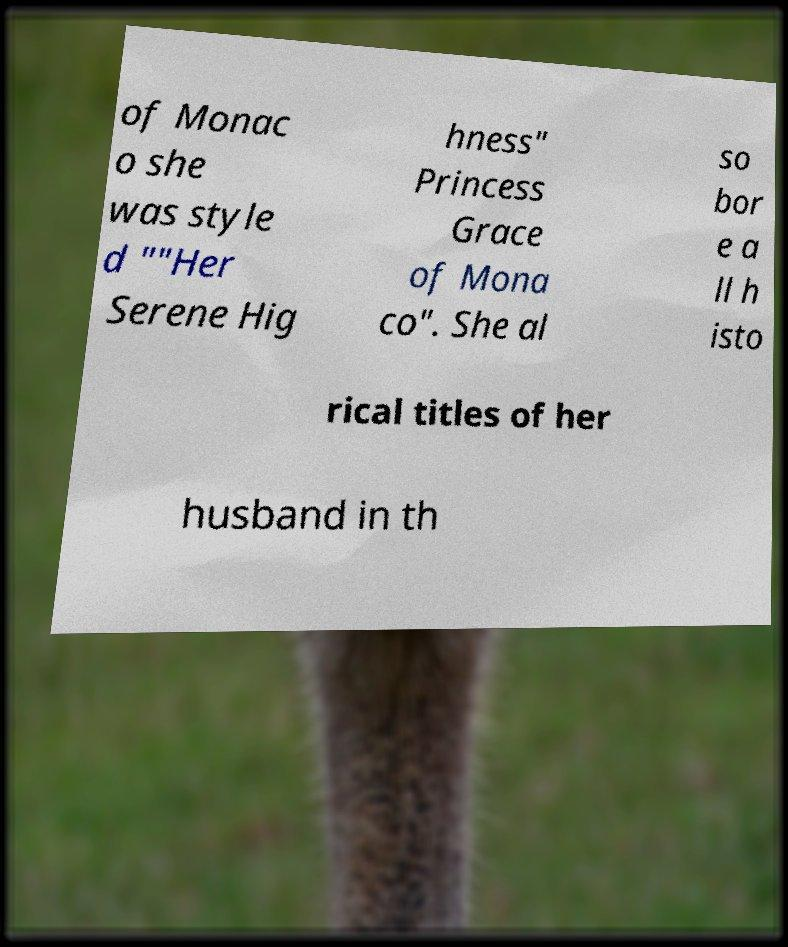For documentation purposes, I need the text within this image transcribed. Could you provide that? of Monac o she was style d ""Her Serene Hig hness" Princess Grace of Mona co". She al so bor e a ll h isto rical titles of her husband in th 